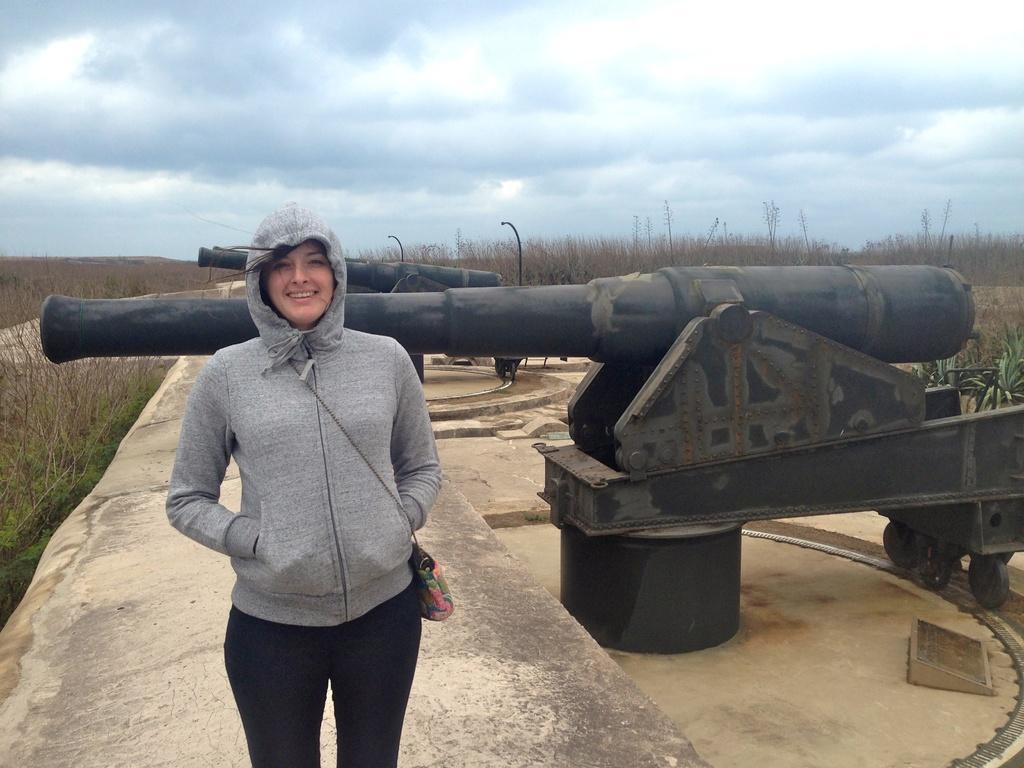Describe this image in one or two sentences. In this image there is a woman standing in the center and smiling. In the background there are cannons and there are dry trees and the sky is cloudy. 